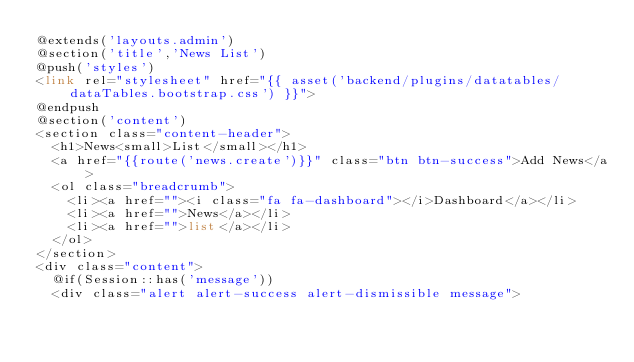Convert code to text. <code><loc_0><loc_0><loc_500><loc_500><_PHP_>@extends('layouts.admin')
@section('title','News List')
@push('styles')
<link rel="stylesheet" href="{{ asset('backend/plugins/datatables/dataTables.bootstrap.css') }}">
@endpush
@section('content')
<section class="content-header">
	<h1>News<small>List</small></h1>
	<a href="{{route('news.create')}}" class="btn btn-success">Add News</a>
	<ol class="breadcrumb">
		<li><a href=""><i class="fa fa-dashboard"></i>Dashboard</a></li>
		<li><a href="">News</a></li>
		<li><a href="">list</a></li>
	</ol>
</section>
<div class="content">
	@if(Session::has('message'))
	<div class="alert alert-success alert-dismissible message"></code> 